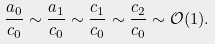<formula> <loc_0><loc_0><loc_500><loc_500>\frac { a _ { 0 } } { c _ { 0 } } \sim \frac { a _ { 1 } } { c _ { 0 } } \sim \frac { c _ { 1 } } { c _ { 0 } } \sim \frac { c _ { 2 } } { c _ { 0 } } \sim { \mathcal { O } } ( 1 ) .</formula> 